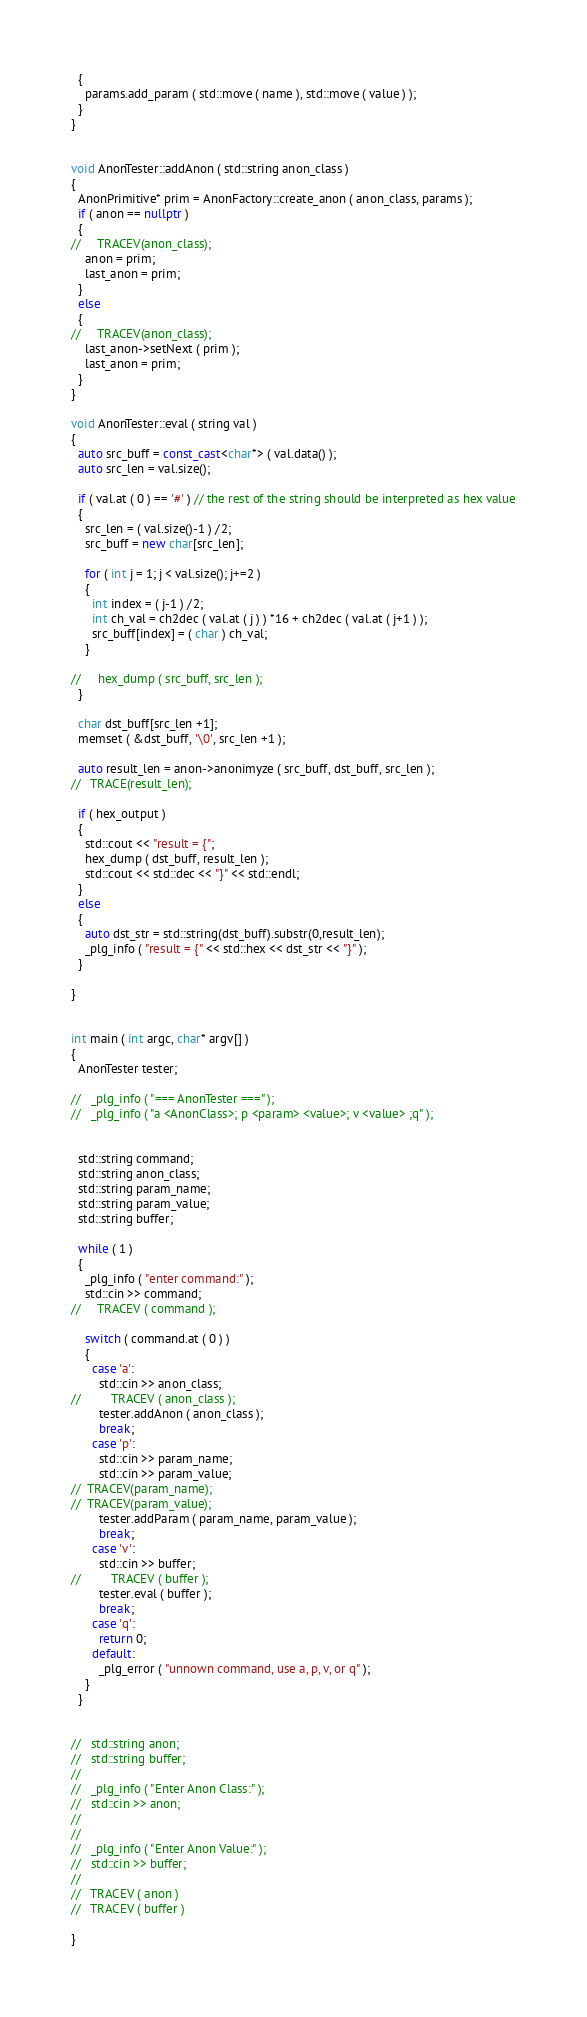Convert code to text. <code><loc_0><loc_0><loc_500><loc_500><_C++_>  {
    params.add_param ( std::move ( name ), std::move ( value ) );
  }
}


void AnonTester::addAnon ( std::string anon_class )
{
  AnonPrimitive* prim = AnonFactory::create_anon ( anon_class, params );
  if ( anon == nullptr )
  {
//     TRACEV(anon_class);
    anon = prim;
    last_anon = prim;
  }
  else
  { 
//     TRACEV(anon_class);
    last_anon->setNext ( prim );
    last_anon = prim;
  }
}

void AnonTester::eval ( string val )
{
  auto src_buff = const_cast<char*> ( val.data() );
  auto src_len = val.size();

  if ( val.at ( 0 ) == '#' ) // the rest of the string should be interpreted as hex value
  {
    src_len = ( val.size()-1 ) /2;
    src_buff = new char[src_len];

    for ( int j = 1; j < val.size(); j+=2 )
    {
      int index = ( j-1 ) /2;
      int ch_val = ch2dec ( val.at ( j ) ) *16 + ch2dec ( val.at ( j+1 ) );
      src_buff[index] = ( char ) ch_val;
    }

//     hex_dump ( src_buff, src_len );
  }

  char dst_buff[src_len +1];
  memset ( &dst_buff, '\0', src_len +1 );

  auto result_len = anon->anonimyze ( src_buff, dst_buff, src_len );
//   TRACE(result_len);
  
  if ( hex_output )
  {
    std::cout << "result = {";
    hex_dump ( dst_buff, result_len );
    std::cout << std::dec << "}" << std::endl;
  }
  else
  {
    auto dst_str = std::string(dst_buff).substr(0,result_len);
    _plg_info ( "result = {" << std::hex << dst_str << "}" );
  }

}


int main ( int argc, char* argv[] )
{
  AnonTester tester;

//   _plg_info ( "=== AnonTester ===" );
//   _plg_info ( "a <AnonClass>; p <param> <value>; v <value> ;q" );


  std::string command;
  std::string anon_class;
  std::string param_name;
  std::string param_value;
  std::string buffer;

  while ( 1 )
  {
    _plg_info ( "enter command:" );
    std::cin >> command;
//     TRACEV ( command );

    switch ( command.at ( 0 ) )
    {
      case 'a':
        std::cin >> anon_class;
//         TRACEV ( anon_class );
        tester.addAnon ( anon_class );
        break;
      case 'p':
        std::cin >> param_name;
        std::cin >> param_value;
//  TRACEV(param_name);
//  TRACEV(param_value);
        tester.addParam ( param_name, param_value );
        break;
      case 'v':
        std::cin >> buffer;
//         TRACEV ( buffer );
        tester.eval ( buffer );
        break;
      case 'q':
        return 0;
      default:
        _plg_error ( "unnown command, use a, p, v, or q" );
    }
  }


//   std::string anon;
//   std::string buffer;
//
//   _plg_info ( "Enter Anon Class:" );
//   std::cin >> anon;
//
//
//   _plg_info ( "Enter Anon Value:" );
//   std::cin >> buffer;
//
//   TRACEV ( anon )
//   TRACEV ( buffer )

}
</code> 